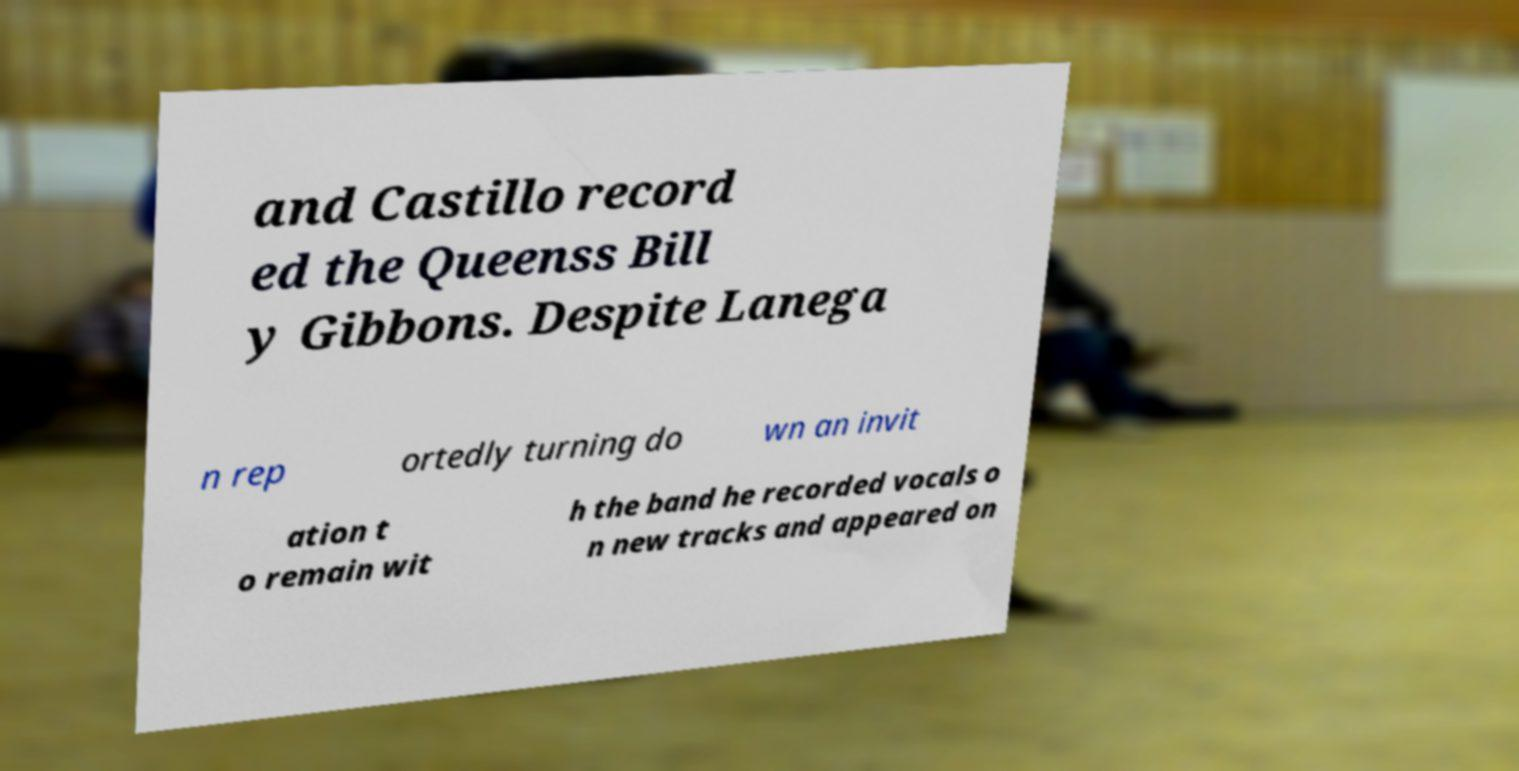Can you accurately transcribe the text from the provided image for me? and Castillo record ed the Queenss Bill y Gibbons. Despite Lanega n rep ortedly turning do wn an invit ation t o remain wit h the band he recorded vocals o n new tracks and appeared on 